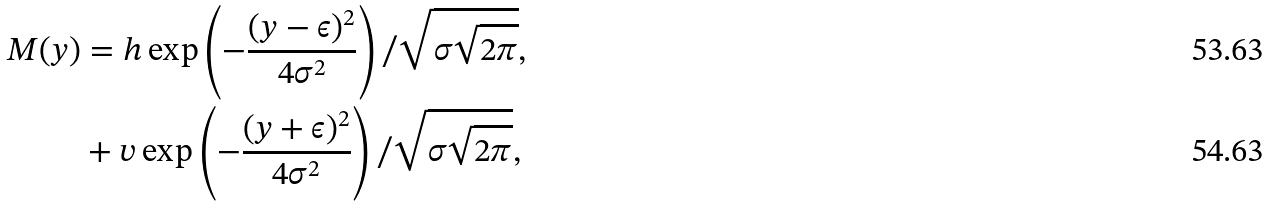<formula> <loc_0><loc_0><loc_500><loc_500>M ( y ) & = h \exp \left ( - \frac { ( y - \epsilon ) ^ { 2 } } { 4 \sigma ^ { 2 } } \right ) / \sqrt { \sigma \sqrt { 2 \pi } } , \\ & + v \exp \left ( - \frac { ( y + \epsilon ) ^ { 2 } } { 4 \sigma ^ { 2 } } \right ) / \sqrt { \sigma \sqrt { 2 \pi } } ,</formula> 